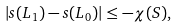<formula> <loc_0><loc_0><loc_500><loc_500>| s ( L _ { 1 } ) - s ( L _ { 0 } ) | \leq - \chi ( S ) ,</formula> 